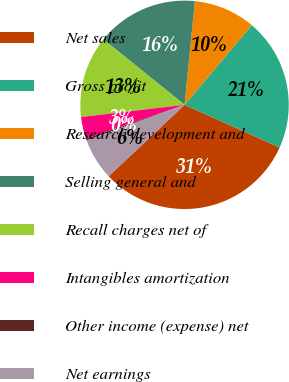Convert chart to OTSL. <chart><loc_0><loc_0><loc_500><loc_500><pie_chart><fcel>Net sales<fcel>Gross profit<fcel>Research development and<fcel>Selling general and<fcel>Recall charges net of<fcel>Intangibles amortization<fcel>Other income (expense) net<fcel>Net earnings<nl><fcel>31.28%<fcel>20.55%<fcel>9.58%<fcel>15.78%<fcel>12.68%<fcel>3.38%<fcel>0.28%<fcel>6.48%<nl></chart> 